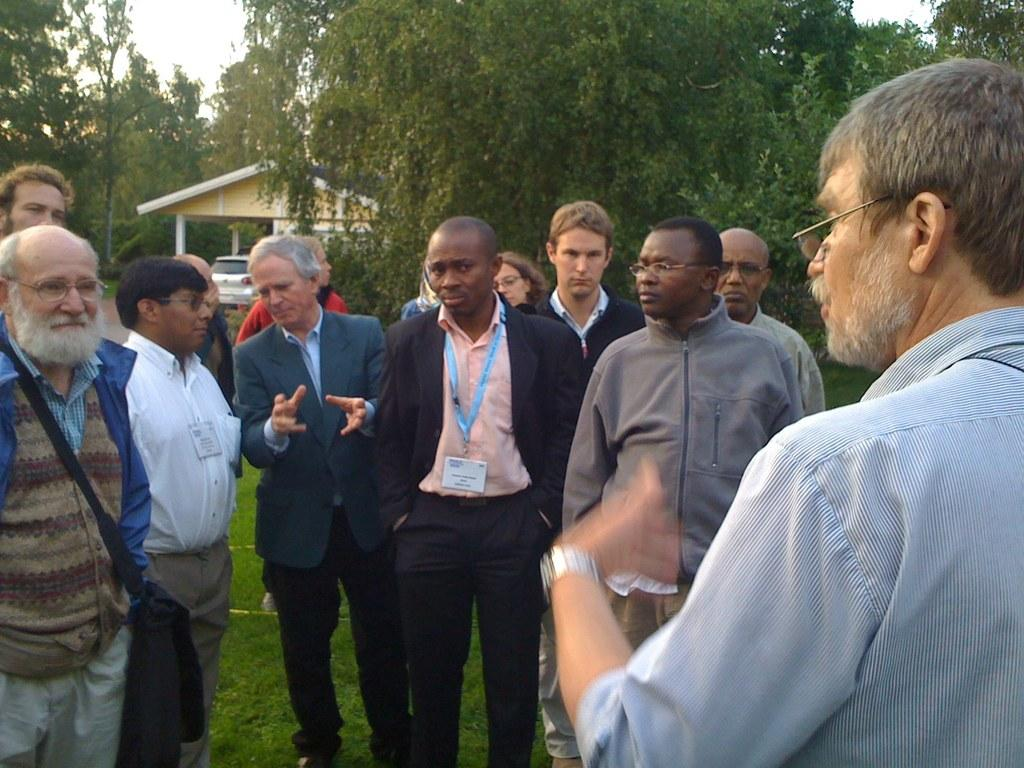How many people are in the image? There is a group of people in the image. Where are the people standing? The people are standing on the grass. What can be seen in the background of the image? There are trees, a house, and a car in the background of the image. How many cars are visible in the image? There is only one car visible in the background of the image. What type of cars are present in the image? The image only shows one car, so it is not possible to determine the type of cars present. 